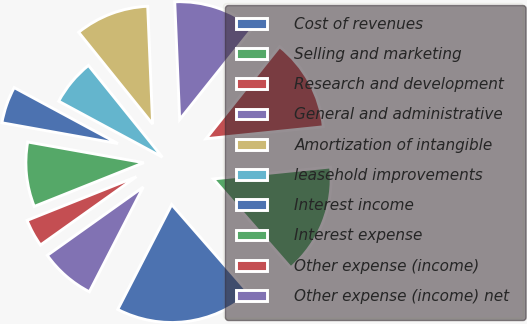Convert chart to OTSL. <chart><loc_0><loc_0><loc_500><loc_500><pie_chart><fcel>Cost of revenues<fcel>Selling and marketing<fcel>Research and development<fcel>General and administrative<fcel>Amortization of intangible<fcel>leasehold improvements<fcel>Interest income<fcel>Interest expense<fcel>Other expense (income)<fcel>Other expense (income) net<nl><fcel>18.99%<fcel>15.19%<fcel>12.66%<fcel>11.39%<fcel>10.13%<fcel>6.33%<fcel>5.06%<fcel>8.86%<fcel>3.8%<fcel>7.59%<nl></chart> 